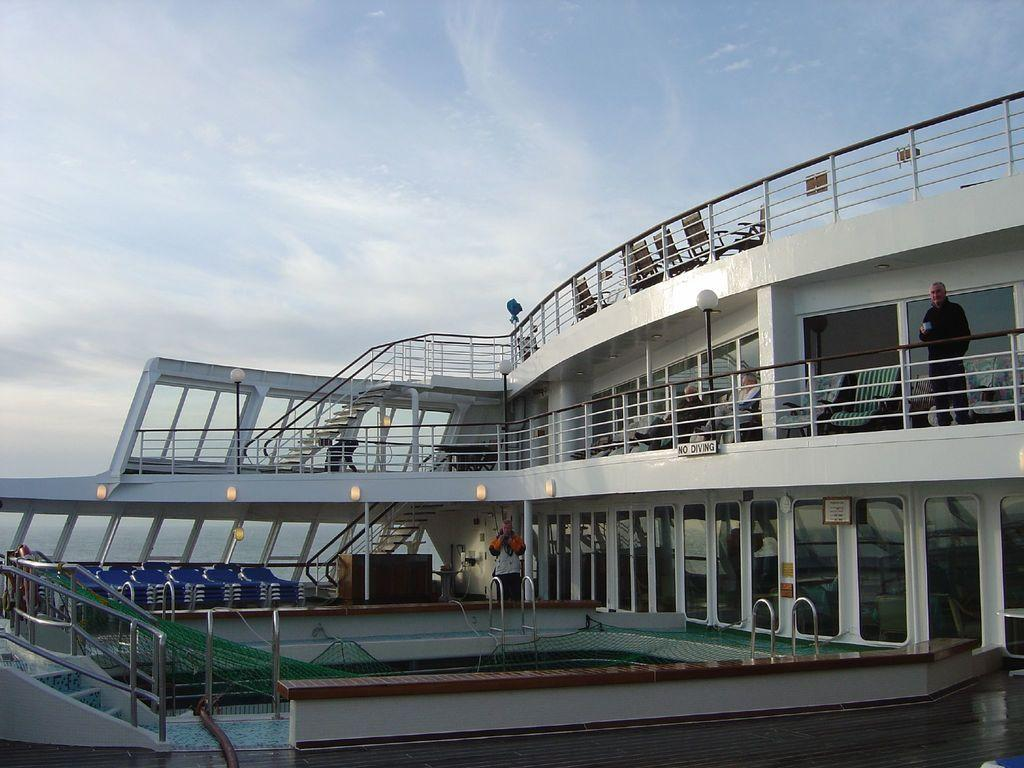What type of structure is present in the image? There is a building in the image. What type of furniture is visible in the image? There are chairs in the image. Are there any people present in the image? Yes, there are people in the image. What recreational feature can be seen in the image? There is a swimming pool in the image. What architectural element is located on the left side of the image? There are stairs on the left side of the image. What type of cabbage is being used as a decoration in the image? There is no cabbage present in the image. What type of beast can be seen roaming around the swimming pool in the image? There are no beasts present in the image; it features a building, chairs, people, a swimming pool, and stairs. 